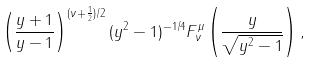<formula> <loc_0><loc_0><loc_500><loc_500>\left ( \frac { y + 1 } { y - 1 } \right ) ^ { ( \nu + \frac { 1 } { 2 } ) / 2 } ( y ^ { 2 } - 1 ) ^ { - 1 / 4 } F _ { \nu } ^ { \mu } \left ( \frac { y } { \sqrt { y ^ { 2 } - 1 } } \right ) ,</formula> 